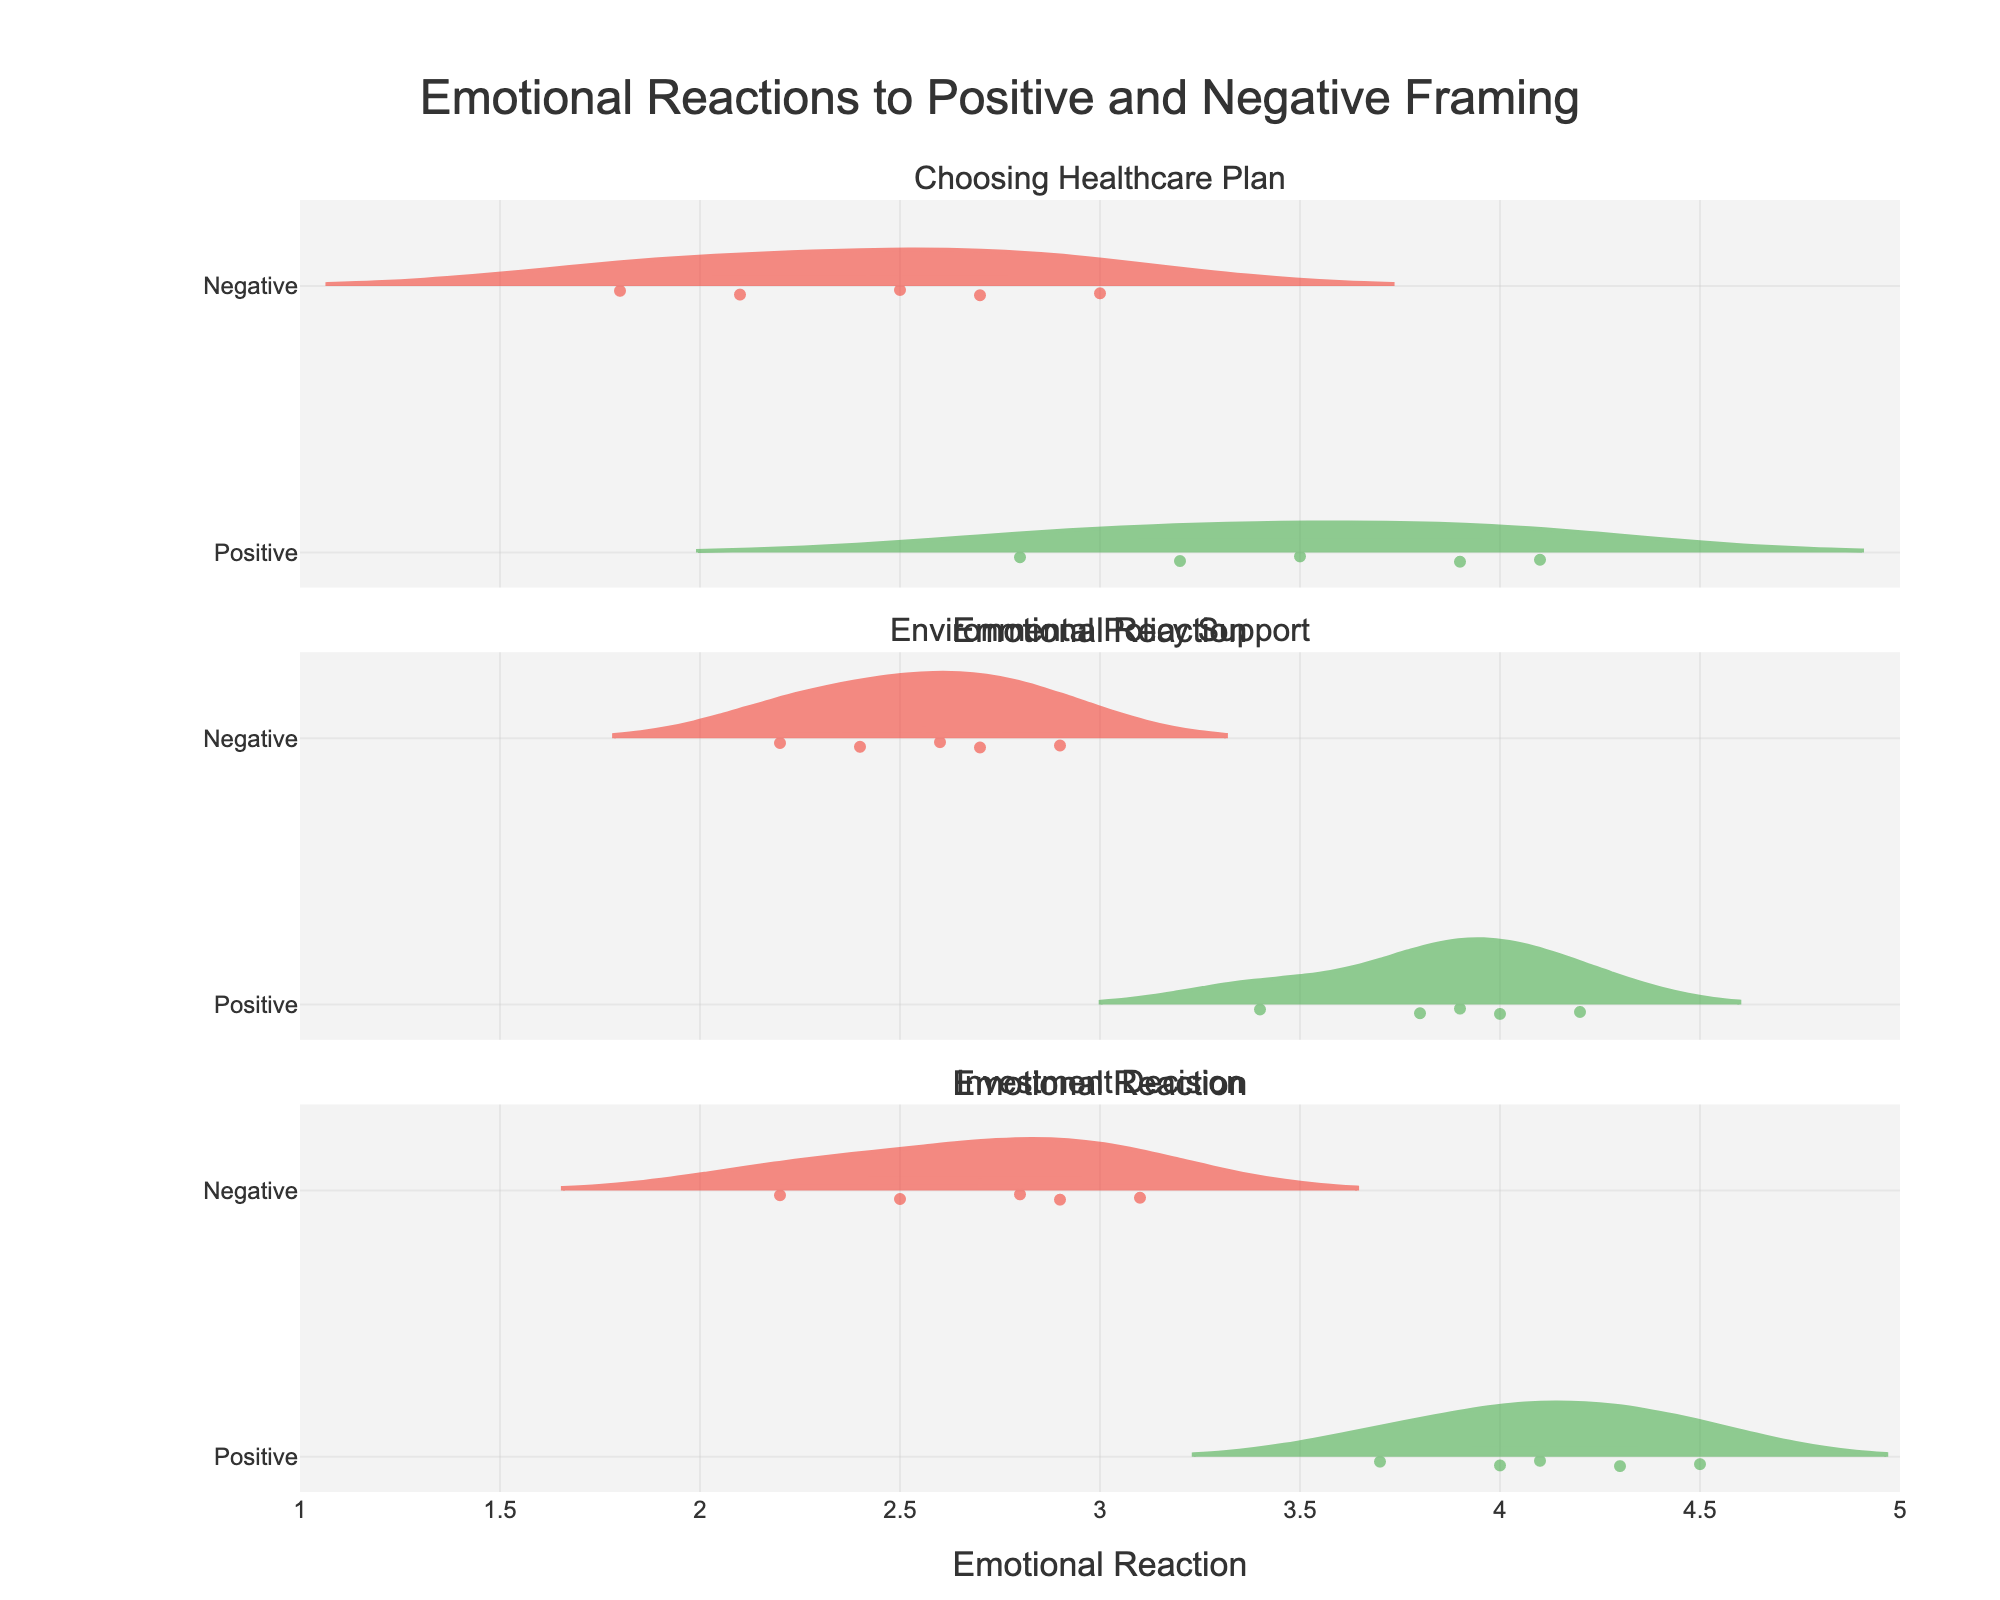what is the title of the plot? The title of the plot is displayed prominently at the top of the figure. It typically provides a summary of the plot's purpose or the data it represents.
Answer: Emotional Reactions to Positive and Negative Framing How are positive and negative frames visually distinguished in the plot? The plot uses different colors and labels to distinguish between positive and negative frames. Specifically, positive frames are represented in green, while negative frames are shown in red.
Answer: By green and red colors What's the general trend in emotional reactions to positive framing compared to negative framing across all scenarios? Generally, for all scenarios ('Choosing Healthcare Plan,' 'Environmental Policy Support,' and 'Investment Decision'), the positive frames tend to have higher emotional reactions than the negative frames. This pattern indicates that positive framing elicits stronger emotional reactions.
Answer: Positive frames have higher emotional reactions For the scenario 'Environmental Policy Support', which frame type has a higher median emotional reaction? By examining the middle horizontal point of the violin plots for 'Environmental Policy Support,' we can see that the median line for the positive frame is positioned higher than that for the negative frame.
Answer: Positive frame In the 'Investment Decision' scenario, does the positive frame's highest emotional reaction overlap with the negative frame's reaction range? The highest emotional reaction for 'Investment Decision' under the positive frame appears around 4.5. If we look at the range of the negative frame, it extends up to around 3.1. There is no overlap, indicating distinct upper ranges.
Answer: No Which scenario shows the largest difference in mean emotional reaction between positive and negative framing? To find which scenario has the largest difference in mean emotional reaction, we need to compare the mean line of each frame within each violin plot. The 'Investment Decision' scenario shows the most considerable difference, with higher means in the positive frame vs. the negative.
Answer: Investment Decision In the 'Choosing Healthcare Plan' scenario, what is the range of emotional reactions for the negative frame? The range of emotional reactions for any frame can be seen from the bottom to the top of the violin plot. For the negative frame in 'Choosing Healthcare Plan,' this range is approximately from 1.8 to 3.0.
Answer: 1.8 to 3.0 Are the distributions of emotional reactions for the positive and negative frames symmetric or skewed in the 'Environmental Policy Support' scenario? By analyzing the shape of the violin plots for the 'Environmental Policy Support' scenario, we notice that both frames are somewhat skewed rather than symmetric. The positive frame is slightly skewed right, and the negative frame is slightly skewed left.
Answer: Skewed Which scenario has the most spread (variance) in emotional reactions for the negative frame? The spread of the reactions is indicated by the width of the violin plot. By comparing the negative frames across all scenarios ('Choosing Healthcare Plan,' 'Environmental Policy Support,' and 'Investment Decision'), we see the negative frame in 'Environmental Policy Support' shows the widest distribution, signifying the most variance.
Answer: Environmental Policy Support 